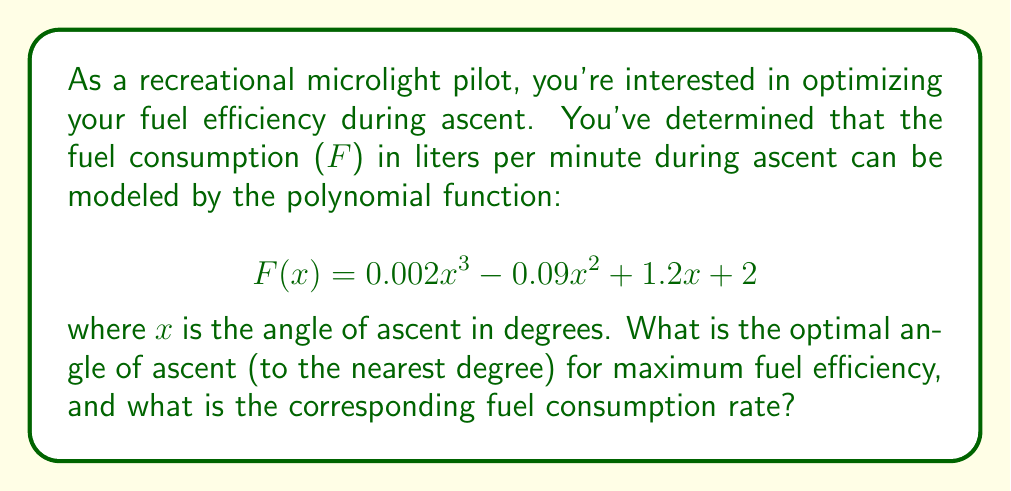What is the answer to this math problem? To find the optimal angle of ascent for maximum fuel efficiency, we need to find the minimum point of the fuel consumption function. This occurs where the derivative of the function equals zero.

1) First, let's find the derivative of F(x):
   $$ F'(x) = 0.006x^2 - 0.18x + 1.2 $$

2) Set the derivative equal to zero:
   $$ 0.006x^2 - 0.18x + 1.2 = 0 $$

3) This is a quadratic equation. We can solve it using the quadratic formula:
   $$ x = \frac{-b \pm \sqrt{b^2 - 4ac}}{2a} $$
   where $a = 0.006$, $b = -0.18$, and $c = 1.2$

4) Substituting these values:
   $$ x = \frac{0.18 \pm \sqrt{(-0.18)^2 - 4(0.006)(1.2)}}{2(0.006)} $$

5) Simplifying:
   $$ x = \frac{0.18 \pm \sqrt{0.0324 - 0.0288}}{0.012} = \frac{0.18 \pm \sqrt{0.0036}}{0.012} = \frac{0.18 \pm 0.06}{0.012} $$

6) This gives us two solutions:
   $$ x_1 = \frac{0.18 + 0.06}{0.012} = 20 $$
   $$ x_2 = \frac{0.18 - 0.06}{0.012} = 10 $$

7) To determine which solution gives the minimum, we can check the second derivative:
   $$ F''(x) = 0.012x - 0.18 $$
   At x = 20, F''(20) = 0.06 > 0, indicating a minimum.
   At x = 10, F''(10) = -0.06 < 0, indicating a maximum.

8) Therefore, the optimal angle of ascent is 20 degrees.

9) To find the corresponding fuel consumption rate, we substitute x = 20 into the original function:
   $$ F(20) = 0.002(20)^3 - 0.09(20)^2 + 1.2(20) + 2 $$
   $$ = 16 - 36 + 24 + 2 = 6 $$

Thus, the fuel consumption rate at the optimal angle is 6 liters per minute.
Answer: The optimal angle of ascent is 20 degrees, with a corresponding fuel consumption rate of 6 liters per minute. 